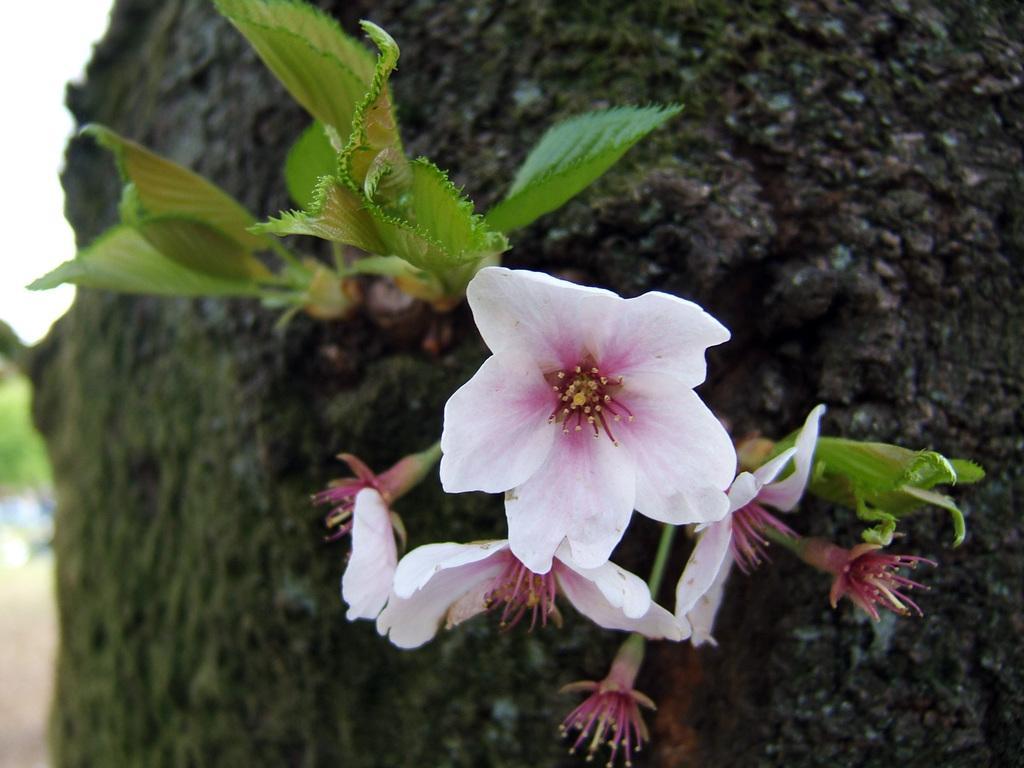Could you give a brief overview of what you see in this image? In this image we can see flowers, leaves, and rock. At the top left corner of the image we can see sky. 